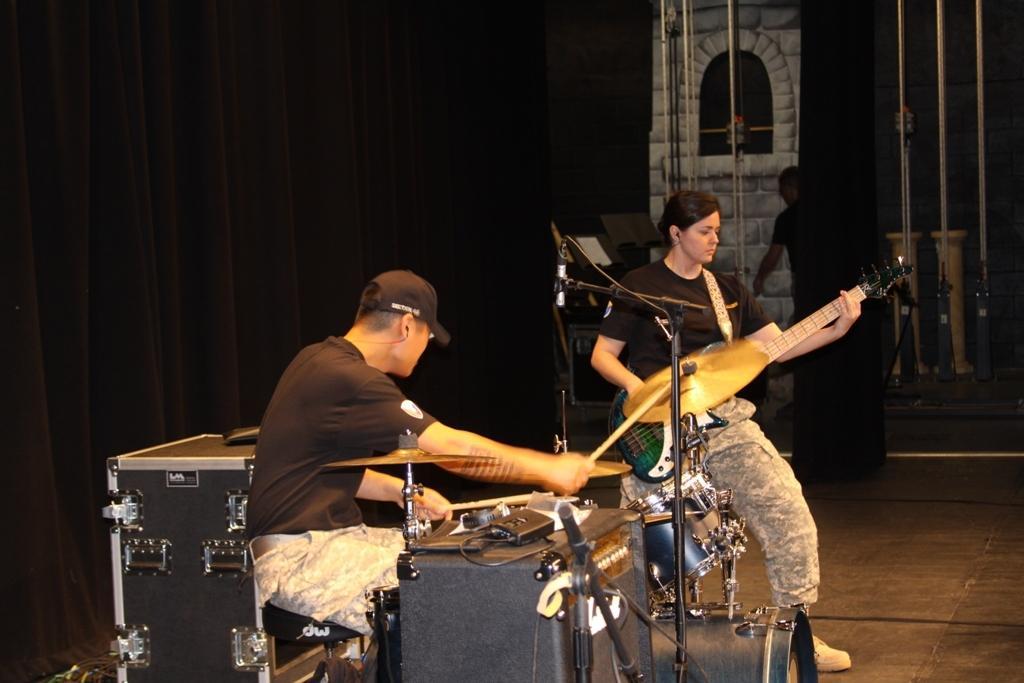Could you give a brief overview of what you see in this image? In this image I can see two people are playing the musical instruments and wearing the black t-shirts and one person with the cap. In the background I can see the curtain. 